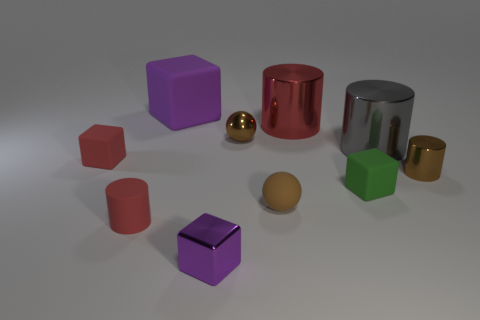Is the color of the tiny metal block the same as the big matte cube?
Offer a very short reply. Yes. There is a rubber thing on the right side of the small brown matte sphere; is it the same shape as the red object to the right of the rubber cylinder?
Provide a short and direct response. No. There is a tiny red matte cylinder to the left of the purple block in front of the small brown metal cylinder; what number of purple things are in front of it?
Your answer should be very brief. 1. What is the material of the large cylinder in front of the small sphere that is behind the rubber sphere that is to the right of the tiny purple cube?
Keep it short and to the point. Metal. Is the red cylinder that is on the right side of the small brown matte sphere made of the same material as the small green block?
Offer a terse response. No. What number of green objects have the same size as the red block?
Your response must be concise. 1. Are there more tiny brown metal things that are on the left side of the gray metal object than gray metallic objects in front of the green block?
Provide a succinct answer. Yes. Is there a tiny shiny object that has the same shape as the large purple rubber thing?
Make the answer very short. Yes. There is a red matte object behind the red cylinder in front of the large red cylinder; what is its size?
Give a very brief answer. Small. The brown object right of the cube that is on the right side of the metallic thing that is to the left of the tiny brown metal sphere is what shape?
Give a very brief answer. Cylinder. 